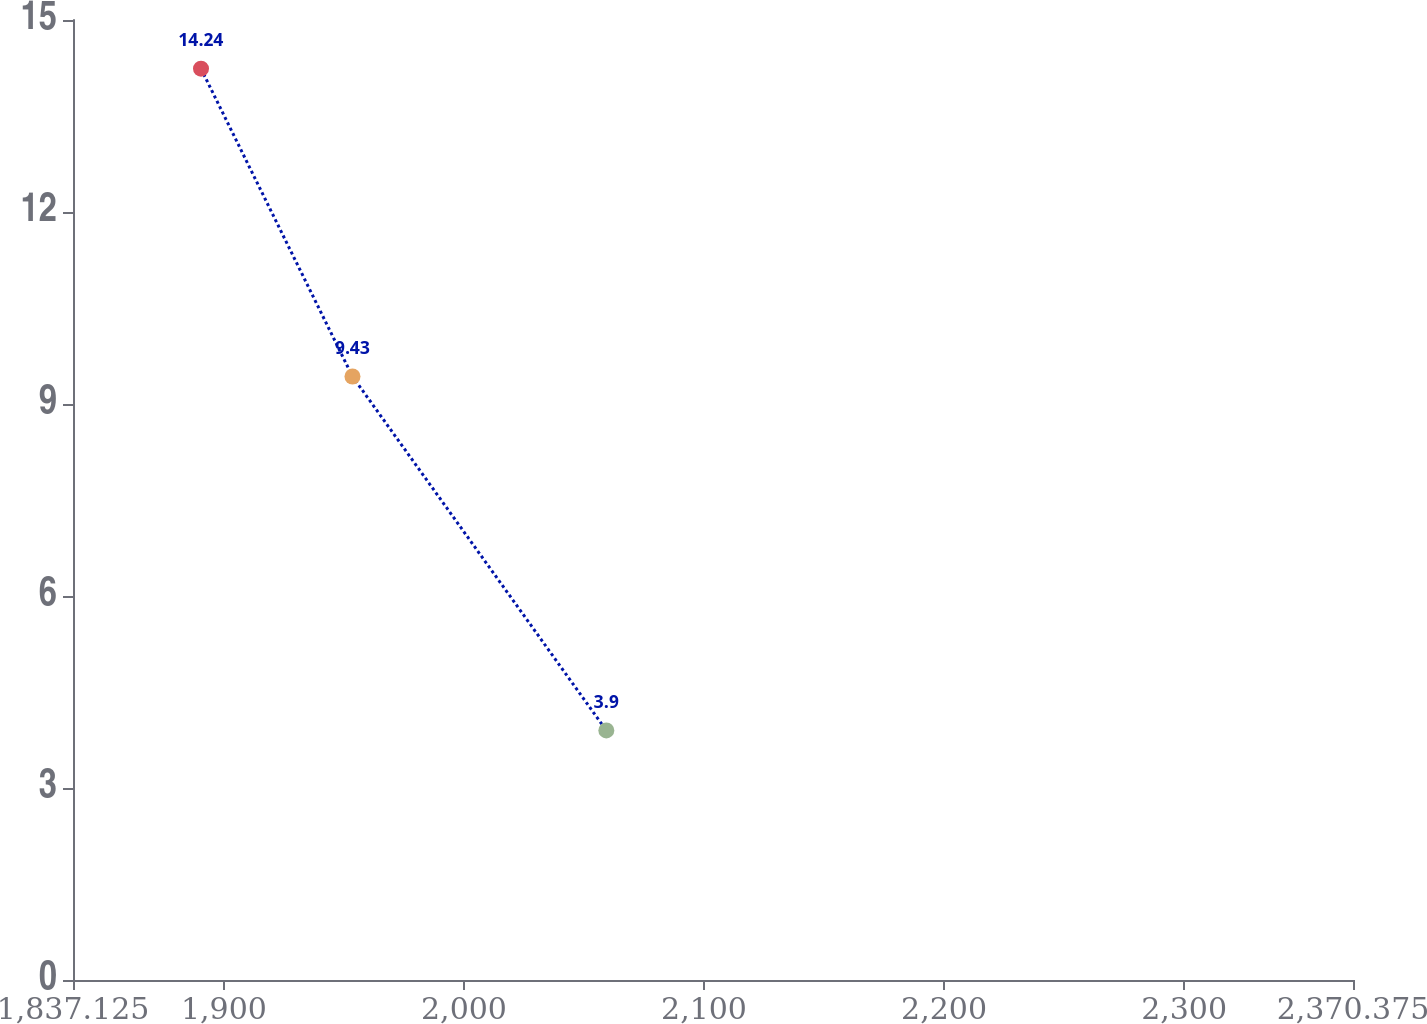Convert chart to OTSL. <chart><loc_0><loc_0><loc_500><loc_500><line_chart><ecel><fcel>Unnamed: 1<nl><fcel>1890.45<fcel>14.24<nl><fcel>1953.56<fcel>9.43<nl><fcel>2059.31<fcel>3.9<nl><fcel>2373.09<fcel>5.26<nl><fcel>2423.7<fcel>0.68<nl></chart> 